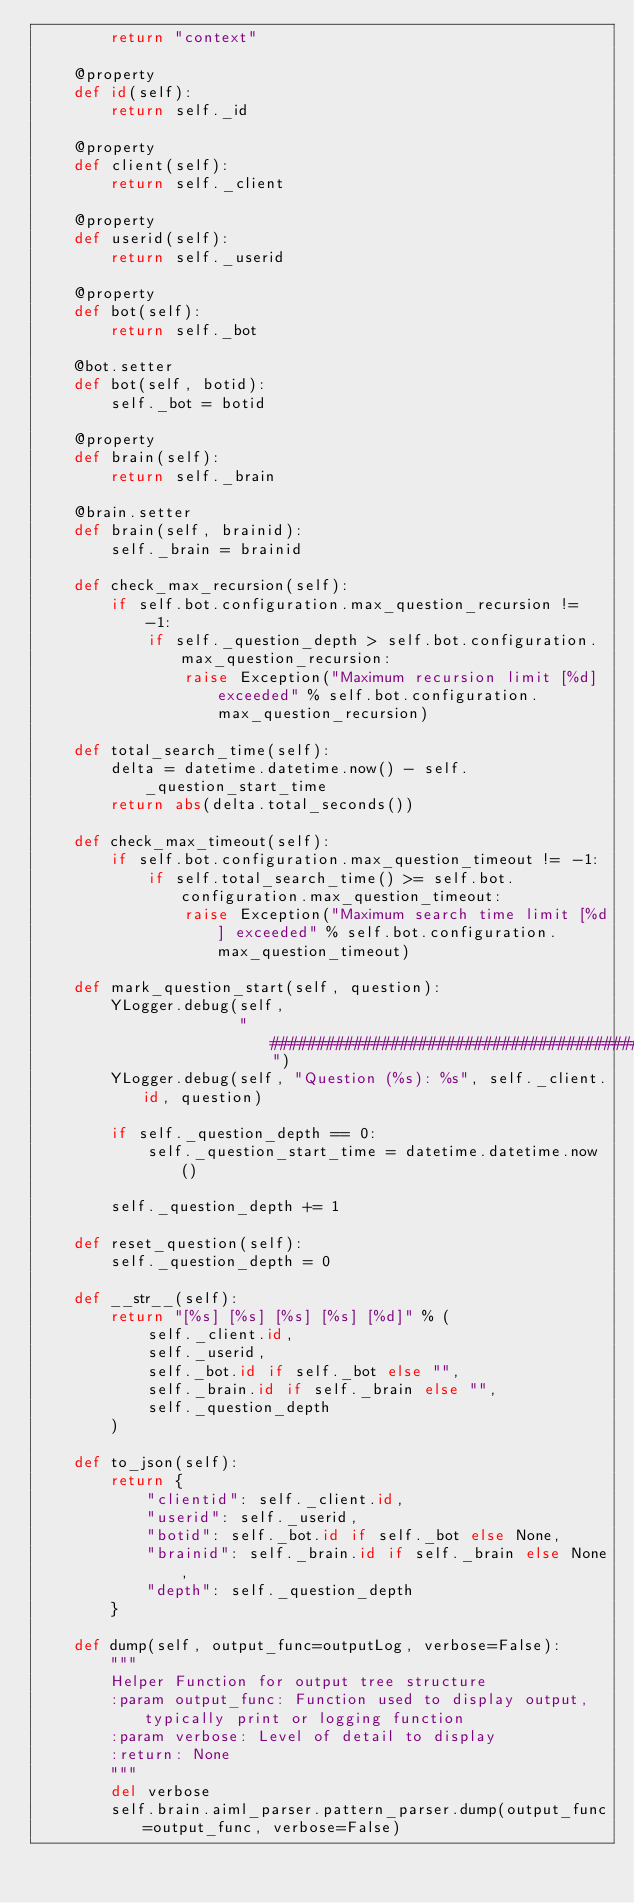<code> <loc_0><loc_0><loc_500><loc_500><_Python_>        return "context"

    @property
    def id(self):
        return self._id

    @property
    def client(self):
        return self._client

    @property
    def userid(self):
        return self._userid

    @property
    def bot(self):
        return self._bot

    @bot.setter
    def bot(self, botid):
        self._bot = botid

    @property
    def brain(self):
        return self._brain

    @brain.setter
    def brain(self, brainid):
        self._brain = brainid

    def check_max_recursion(self):
        if self.bot.configuration.max_question_recursion != -1:
            if self._question_depth > self.bot.configuration.max_question_recursion:
                raise Exception("Maximum recursion limit [%d] exceeded" % self.bot.configuration.max_question_recursion)

    def total_search_time(self):
        delta = datetime.datetime.now() - self._question_start_time
        return abs(delta.total_seconds())

    def check_max_timeout(self):
        if self.bot.configuration.max_question_timeout != -1:
            if self.total_search_time() >= self.bot.configuration.max_question_timeout:
                raise Exception("Maximum search time limit [%d] exceeded" % self.bot.configuration.max_question_timeout)

    def mark_question_start(self, question):
        YLogger.debug(self,
                      "##########################################################################################")
        YLogger.debug(self, "Question (%s): %s", self._client.id, question)

        if self._question_depth == 0:
            self._question_start_time = datetime.datetime.now()

        self._question_depth += 1

    def reset_question(self):
        self._question_depth = 0

    def __str__(self):
        return "[%s] [%s] [%s] [%s] [%d]" % (
            self._client.id,
            self._userid,
            self._bot.id if self._bot else "",
            self._brain.id if self._brain else "",
            self._question_depth
        )

    def to_json(self):
        return {
            "clientid": self._client.id,
            "userid": self._userid,
            "botid": self._bot.id if self._bot else None,
            "brainid": self._brain.id if self._brain else None,
            "depth": self._question_depth
        }

    def dump(self, output_func=outputLog, verbose=False):
        """
        Helper Function for output tree structure
        :param output_func: Function used to display output, typically print or logging function
        :param verbose: Level of detail to display
        :return: None
        """
        del verbose
        self.brain.aiml_parser.pattern_parser.dump(output_func=output_func, verbose=False)
</code> 